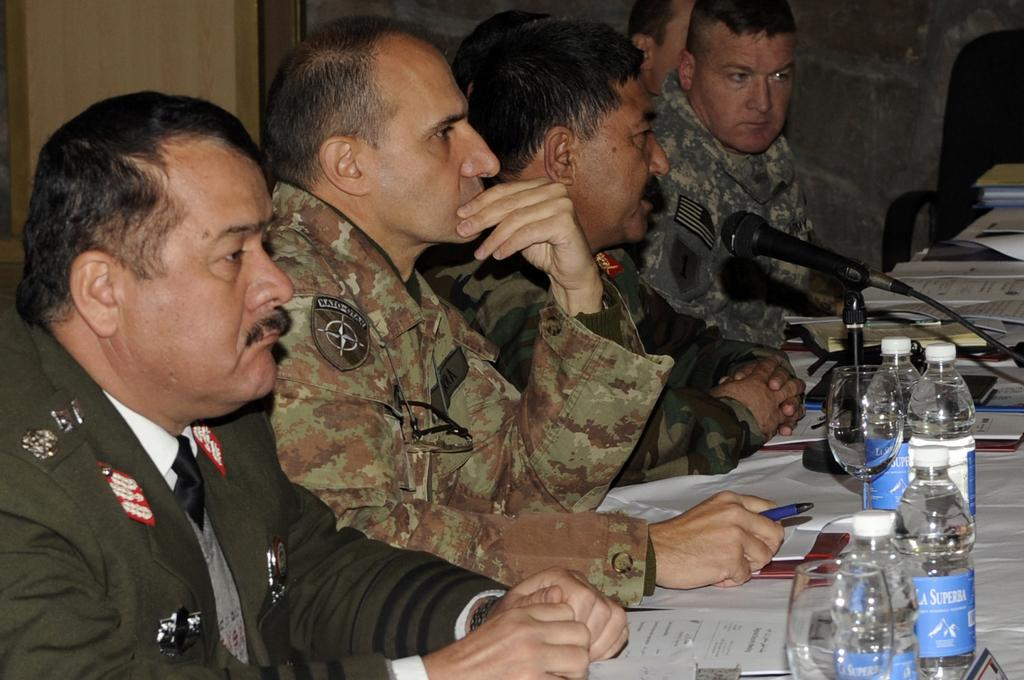What are the people in the image doing? There is a group of people sitting in the image. What objects are on the table in the image? There are papers, wine glasses, a microphone (mike), and bottles on the table. How many chairs are visible in the image? There is at least one chair in the image. What type of teaching method is being demonstrated in the image? There is no teaching method being demonstrated in the image; it simply shows a group of people sitting and objects on a table. 